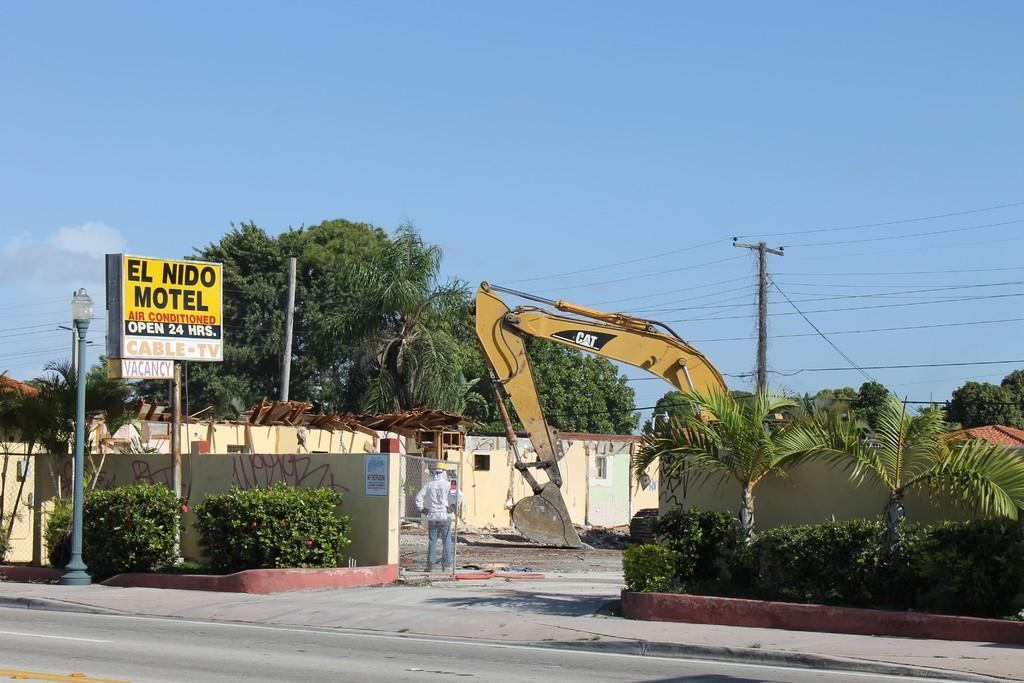What type of machinery can be seen in the image? There is an excavator in the image. What structures are visible in the image? There are buildings in the image. What utility infrastructure is present in the image? Electric poles and electric cables are visible in the image. What type of vegetation can be seen in the image? Trees and bushes are in the image. What type of street furniture is present in the image? There is a street pole and street lights visible in the image. What type of signage is present in the image? An information board is present in the image. What can be seen in the background of the image? The sky is visible in the background of the image. What is your opinion on the excavator's performance in the image? The question is absurd because it asks for an opinion, which cannot be answered definitively based on the facts provided. Is your grandmother in the image? The question is absurd because it asks about a person who is not mentioned in the facts provided. What is your father's opinion on the excavator in the image? The question is absurd because it asks for someone else's opinion, which cannot be answered definitively based on the facts provided. 